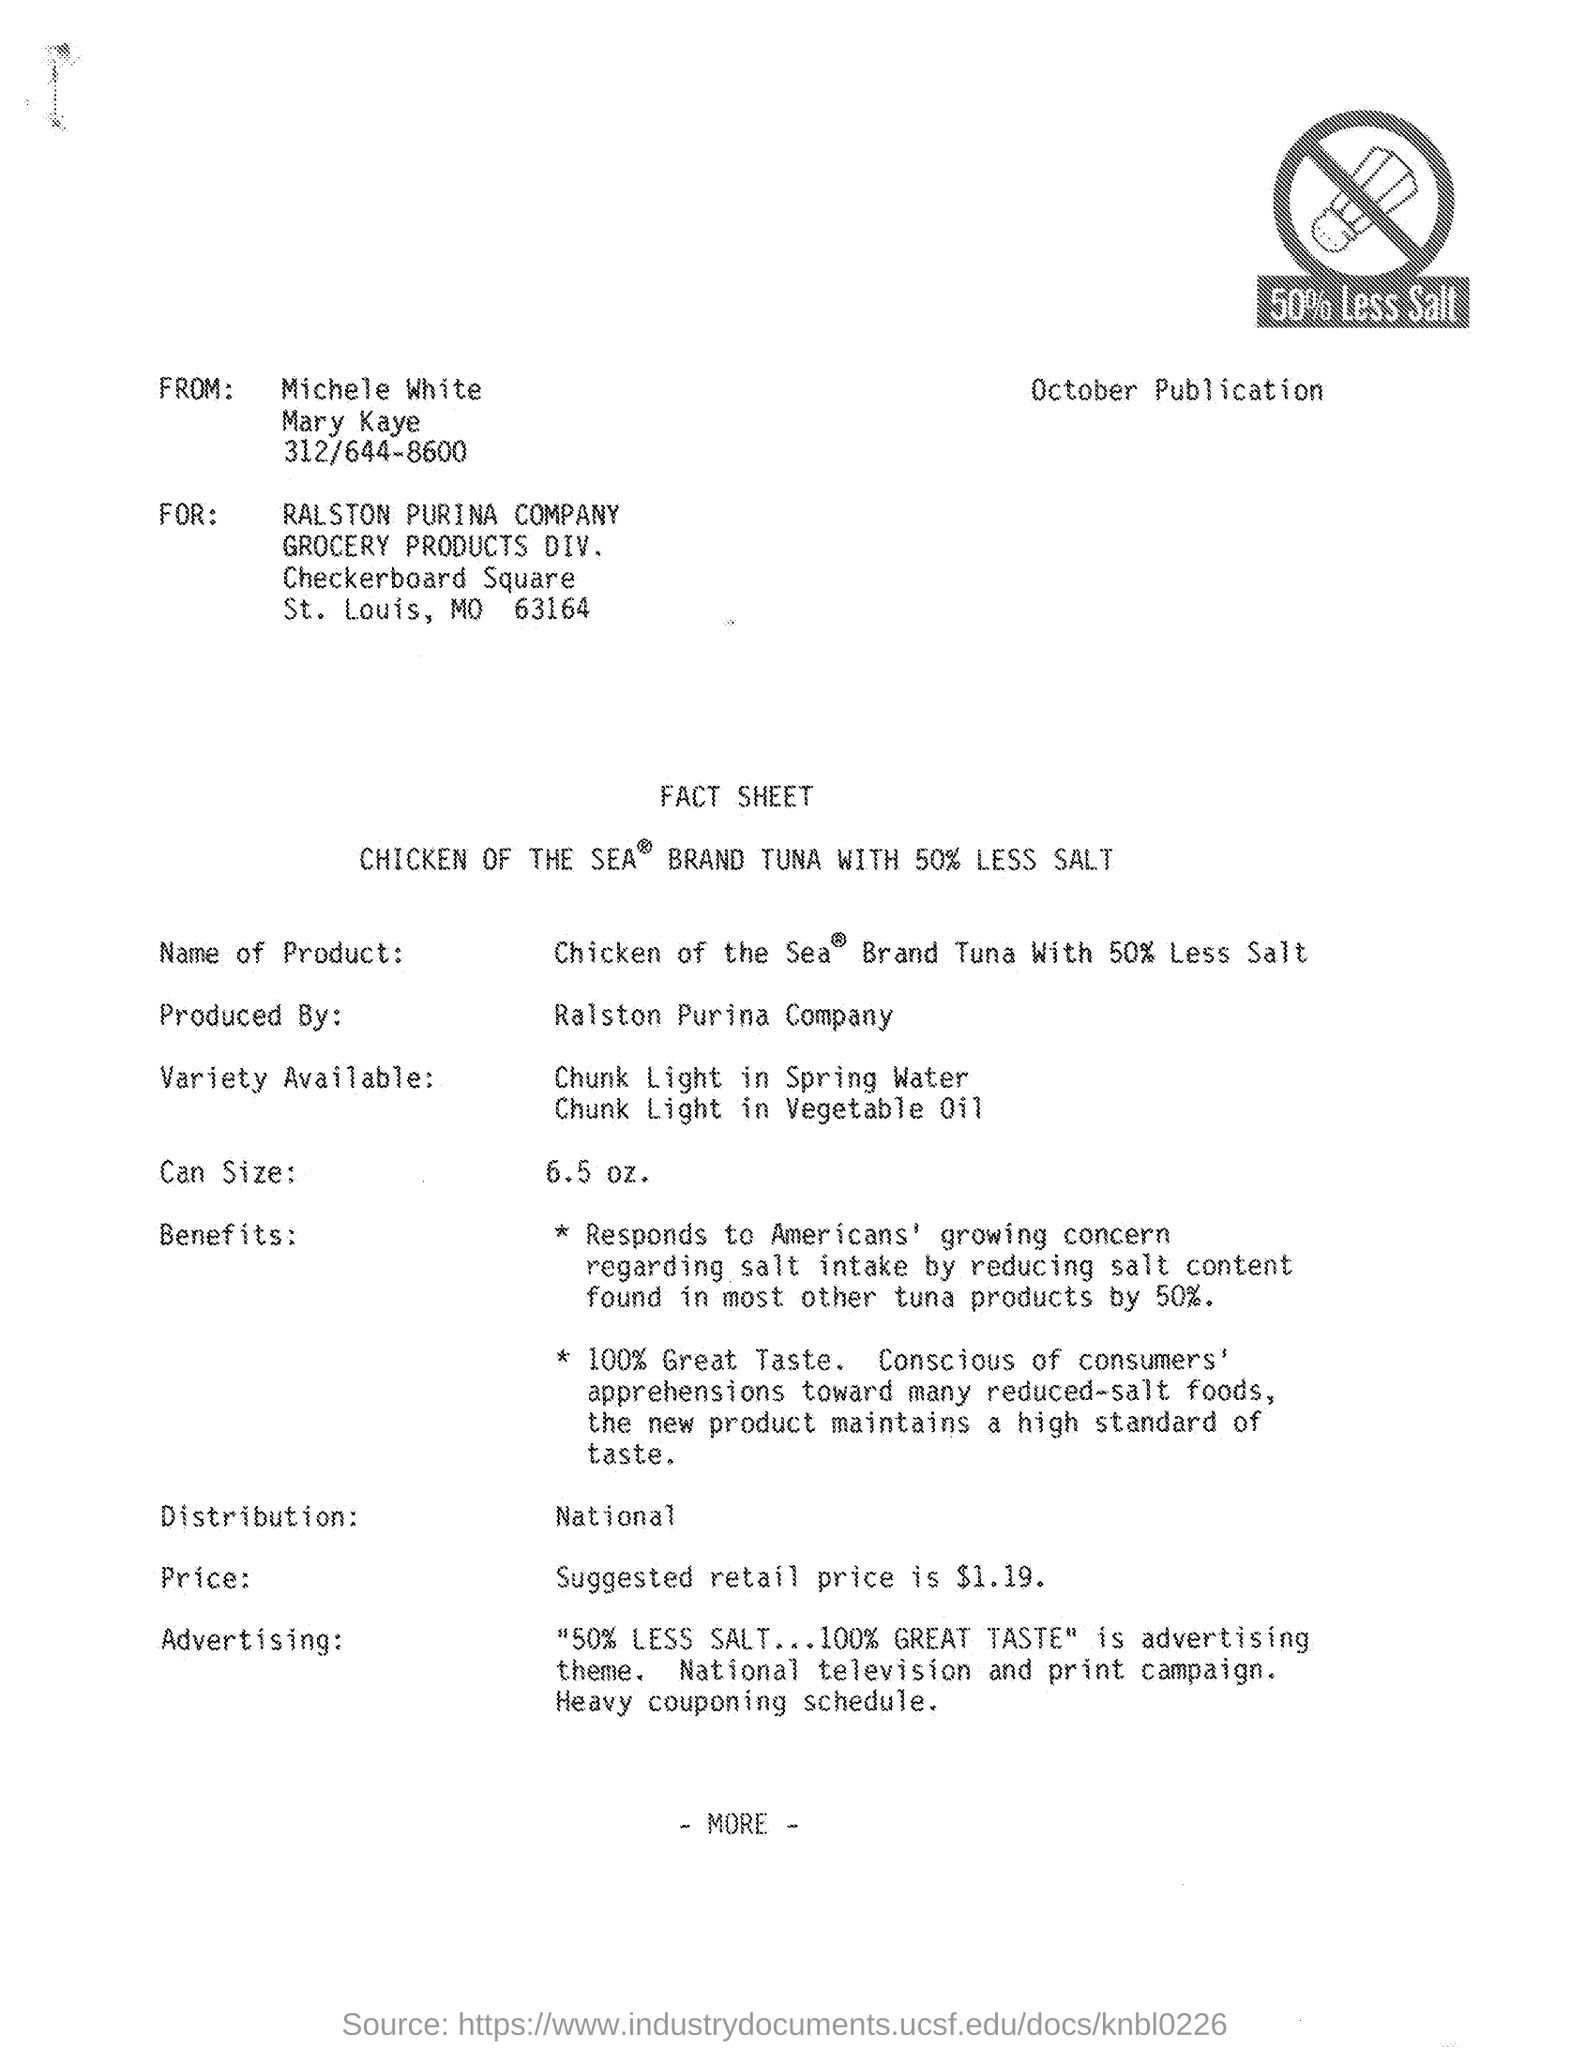What varieties of tuna are mentioned in the fact sheet? The fact sheet mentions two varieties of tuna: Chunk Light in Spring Water and Chunk Light in Vegetable Oil. Are there any health-related benefits highlighted? Yes, the fact sheet highlights that the product responds to concerns about salt intake by reducing the salt content by 50%, which caters to health-conscious consumers. 